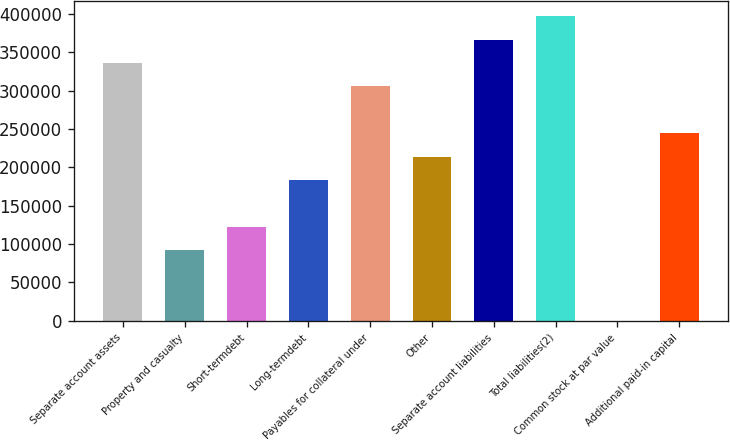<chart> <loc_0><loc_0><loc_500><loc_500><bar_chart><fcel>Separate account assets<fcel>Property and casualty<fcel>Short-termdebt<fcel>Long-termdebt<fcel>Payables for collateral under<fcel>Other<fcel>Separate account liabilities<fcel>Total liabilities(2)<fcel>Common stock at par value<fcel>Additional paid-in capital<nl><fcel>336260<fcel>91713.2<fcel>122282<fcel>183418<fcel>305692<fcel>213987<fcel>366829<fcel>397397<fcel>8<fcel>244555<nl></chart> 